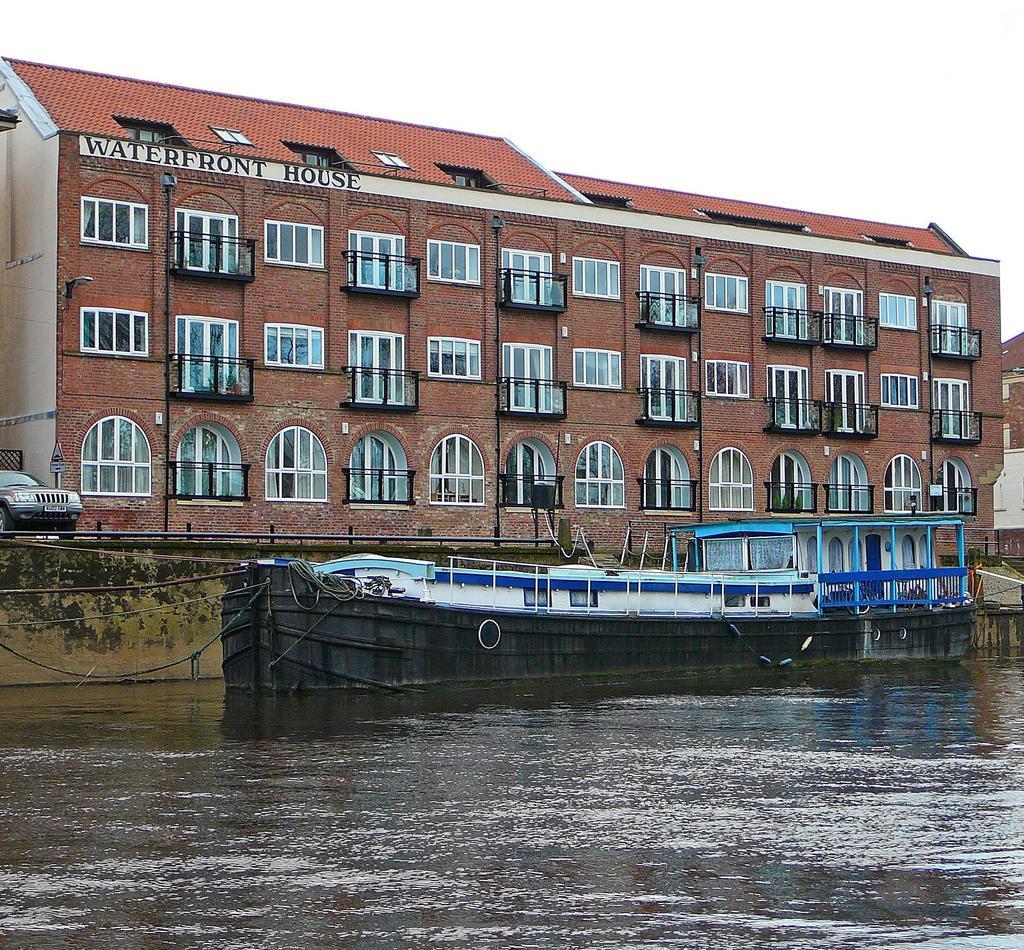Describe this image in one or two sentences. In this picture I see the water in front on which there are boats and in the background I see a car on the left side and I see the buildings and I see the sky. 